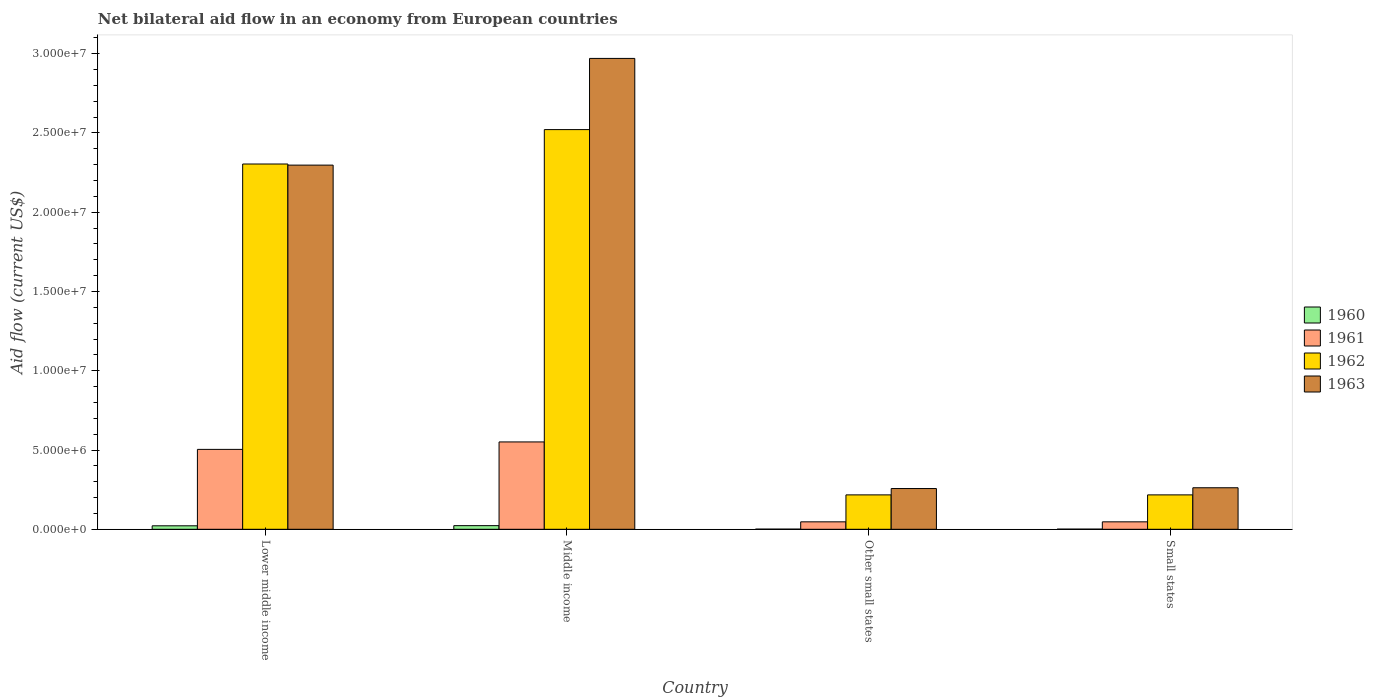How many groups of bars are there?
Offer a very short reply. 4. Are the number of bars per tick equal to the number of legend labels?
Your response must be concise. Yes. Are the number of bars on each tick of the X-axis equal?
Your response must be concise. Yes. How many bars are there on the 3rd tick from the right?
Keep it short and to the point. 4. What is the label of the 1st group of bars from the left?
Keep it short and to the point. Lower middle income. In how many cases, is the number of bars for a given country not equal to the number of legend labels?
Your answer should be compact. 0. What is the net bilateral aid flow in 1963 in Small states?
Provide a succinct answer. 2.62e+06. Across all countries, what is the maximum net bilateral aid flow in 1961?
Provide a short and direct response. 5.51e+06. In which country was the net bilateral aid flow in 1962 maximum?
Provide a short and direct response. Middle income. In which country was the net bilateral aid flow in 1963 minimum?
Give a very brief answer. Other small states. What is the total net bilateral aid flow in 1960 in the graph?
Ensure brevity in your answer.  4.70e+05. What is the difference between the net bilateral aid flow in 1960 in Lower middle income and the net bilateral aid flow in 1962 in Other small states?
Make the answer very short. -1.95e+06. What is the average net bilateral aid flow in 1960 per country?
Provide a succinct answer. 1.18e+05. What is the difference between the net bilateral aid flow of/in 1961 and net bilateral aid flow of/in 1962 in Small states?
Offer a terse response. -1.70e+06. In how many countries, is the net bilateral aid flow in 1961 greater than 6000000 US$?
Offer a terse response. 0. What is the difference between the highest and the second highest net bilateral aid flow in 1963?
Your answer should be very brief. 2.71e+07. What is the difference between the highest and the lowest net bilateral aid flow in 1963?
Keep it short and to the point. 2.71e+07. In how many countries, is the net bilateral aid flow in 1963 greater than the average net bilateral aid flow in 1963 taken over all countries?
Make the answer very short. 2. Is the sum of the net bilateral aid flow in 1962 in Middle income and Small states greater than the maximum net bilateral aid flow in 1960 across all countries?
Your answer should be compact. Yes. Is it the case that in every country, the sum of the net bilateral aid flow in 1963 and net bilateral aid flow in 1960 is greater than the sum of net bilateral aid flow in 1962 and net bilateral aid flow in 1961?
Provide a short and direct response. No. What does the 3rd bar from the right in Other small states represents?
Offer a terse response. 1961. Is it the case that in every country, the sum of the net bilateral aid flow in 1963 and net bilateral aid flow in 1962 is greater than the net bilateral aid flow in 1961?
Keep it short and to the point. Yes. How many bars are there?
Provide a short and direct response. 16. How many countries are there in the graph?
Your answer should be very brief. 4. Are the values on the major ticks of Y-axis written in scientific E-notation?
Offer a terse response. Yes. Does the graph contain any zero values?
Offer a terse response. No. Does the graph contain grids?
Ensure brevity in your answer.  No. How many legend labels are there?
Give a very brief answer. 4. What is the title of the graph?
Give a very brief answer. Net bilateral aid flow in an economy from European countries. Does "1960" appear as one of the legend labels in the graph?
Offer a very short reply. Yes. What is the Aid flow (current US$) in 1961 in Lower middle income?
Your answer should be very brief. 5.04e+06. What is the Aid flow (current US$) of 1962 in Lower middle income?
Offer a very short reply. 2.30e+07. What is the Aid flow (current US$) in 1963 in Lower middle income?
Make the answer very short. 2.30e+07. What is the Aid flow (current US$) in 1960 in Middle income?
Offer a terse response. 2.30e+05. What is the Aid flow (current US$) in 1961 in Middle income?
Your answer should be very brief. 5.51e+06. What is the Aid flow (current US$) of 1962 in Middle income?
Keep it short and to the point. 2.52e+07. What is the Aid flow (current US$) in 1963 in Middle income?
Keep it short and to the point. 2.97e+07. What is the Aid flow (current US$) of 1961 in Other small states?
Provide a short and direct response. 4.70e+05. What is the Aid flow (current US$) in 1962 in Other small states?
Keep it short and to the point. 2.17e+06. What is the Aid flow (current US$) of 1963 in Other small states?
Your answer should be compact. 2.57e+06. What is the Aid flow (current US$) in 1960 in Small states?
Your answer should be compact. 10000. What is the Aid flow (current US$) in 1961 in Small states?
Give a very brief answer. 4.70e+05. What is the Aid flow (current US$) of 1962 in Small states?
Provide a short and direct response. 2.17e+06. What is the Aid flow (current US$) in 1963 in Small states?
Make the answer very short. 2.62e+06. Across all countries, what is the maximum Aid flow (current US$) in 1961?
Keep it short and to the point. 5.51e+06. Across all countries, what is the maximum Aid flow (current US$) of 1962?
Your response must be concise. 2.52e+07. Across all countries, what is the maximum Aid flow (current US$) of 1963?
Offer a terse response. 2.97e+07. Across all countries, what is the minimum Aid flow (current US$) of 1960?
Your response must be concise. 10000. Across all countries, what is the minimum Aid flow (current US$) of 1961?
Offer a very short reply. 4.70e+05. Across all countries, what is the minimum Aid flow (current US$) in 1962?
Make the answer very short. 2.17e+06. Across all countries, what is the minimum Aid flow (current US$) of 1963?
Your response must be concise. 2.57e+06. What is the total Aid flow (current US$) of 1961 in the graph?
Offer a very short reply. 1.15e+07. What is the total Aid flow (current US$) in 1962 in the graph?
Offer a very short reply. 5.26e+07. What is the total Aid flow (current US$) of 1963 in the graph?
Offer a very short reply. 5.79e+07. What is the difference between the Aid flow (current US$) of 1960 in Lower middle income and that in Middle income?
Give a very brief answer. -10000. What is the difference between the Aid flow (current US$) of 1961 in Lower middle income and that in Middle income?
Make the answer very short. -4.70e+05. What is the difference between the Aid flow (current US$) in 1962 in Lower middle income and that in Middle income?
Keep it short and to the point. -2.17e+06. What is the difference between the Aid flow (current US$) of 1963 in Lower middle income and that in Middle income?
Provide a succinct answer. -6.73e+06. What is the difference between the Aid flow (current US$) in 1960 in Lower middle income and that in Other small states?
Ensure brevity in your answer.  2.10e+05. What is the difference between the Aid flow (current US$) in 1961 in Lower middle income and that in Other small states?
Provide a short and direct response. 4.57e+06. What is the difference between the Aid flow (current US$) in 1962 in Lower middle income and that in Other small states?
Your answer should be very brief. 2.09e+07. What is the difference between the Aid flow (current US$) of 1963 in Lower middle income and that in Other small states?
Offer a terse response. 2.04e+07. What is the difference between the Aid flow (current US$) in 1961 in Lower middle income and that in Small states?
Provide a succinct answer. 4.57e+06. What is the difference between the Aid flow (current US$) in 1962 in Lower middle income and that in Small states?
Make the answer very short. 2.09e+07. What is the difference between the Aid flow (current US$) of 1963 in Lower middle income and that in Small states?
Give a very brief answer. 2.04e+07. What is the difference between the Aid flow (current US$) in 1961 in Middle income and that in Other small states?
Offer a terse response. 5.04e+06. What is the difference between the Aid flow (current US$) of 1962 in Middle income and that in Other small states?
Ensure brevity in your answer.  2.30e+07. What is the difference between the Aid flow (current US$) of 1963 in Middle income and that in Other small states?
Ensure brevity in your answer.  2.71e+07. What is the difference between the Aid flow (current US$) of 1960 in Middle income and that in Small states?
Give a very brief answer. 2.20e+05. What is the difference between the Aid flow (current US$) in 1961 in Middle income and that in Small states?
Keep it short and to the point. 5.04e+06. What is the difference between the Aid flow (current US$) of 1962 in Middle income and that in Small states?
Offer a very short reply. 2.30e+07. What is the difference between the Aid flow (current US$) of 1963 in Middle income and that in Small states?
Ensure brevity in your answer.  2.71e+07. What is the difference between the Aid flow (current US$) in 1962 in Other small states and that in Small states?
Your answer should be very brief. 0. What is the difference between the Aid flow (current US$) in 1963 in Other small states and that in Small states?
Make the answer very short. -5.00e+04. What is the difference between the Aid flow (current US$) in 1960 in Lower middle income and the Aid flow (current US$) in 1961 in Middle income?
Your answer should be compact. -5.29e+06. What is the difference between the Aid flow (current US$) in 1960 in Lower middle income and the Aid flow (current US$) in 1962 in Middle income?
Offer a terse response. -2.50e+07. What is the difference between the Aid flow (current US$) of 1960 in Lower middle income and the Aid flow (current US$) of 1963 in Middle income?
Ensure brevity in your answer.  -2.95e+07. What is the difference between the Aid flow (current US$) in 1961 in Lower middle income and the Aid flow (current US$) in 1962 in Middle income?
Make the answer very short. -2.02e+07. What is the difference between the Aid flow (current US$) in 1961 in Lower middle income and the Aid flow (current US$) in 1963 in Middle income?
Make the answer very short. -2.47e+07. What is the difference between the Aid flow (current US$) of 1962 in Lower middle income and the Aid flow (current US$) of 1963 in Middle income?
Your answer should be compact. -6.66e+06. What is the difference between the Aid flow (current US$) of 1960 in Lower middle income and the Aid flow (current US$) of 1962 in Other small states?
Offer a very short reply. -1.95e+06. What is the difference between the Aid flow (current US$) in 1960 in Lower middle income and the Aid flow (current US$) in 1963 in Other small states?
Give a very brief answer. -2.35e+06. What is the difference between the Aid flow (current US$) in 1961 in Lower middle income and the Aid flow (current US$) in 1962 in Other small states?
Provide a short and direct response. 2.87e+06. What is the difference between the Aid flow (current US$) in 1961 in Lower middle income and the Aid flow (current US$) in 1963 in Other small states?
Provide a succinct answer. 2.47e+06. What is the difference between the Aid flow (current US$) of 1962 in Lower middle income and the Aid flow (current US$) of 1963 in Other small states?
Give a very brief answer. 2.05e+07. What is the difference between the Aid flow (current US$) of 1960 in Lower middle income and the Aid flow (current US$) of 1962 in Small states?
Your response must be concise. -1.95e+06. What is the difference between the Aid flow (current US$) in 1960 in Lower middle income and the Aid flow (current US$) in 1963 in Small states?
Give a very brief answer. -2.40e+06. What is the difference between the Aid flow (current US$) of 1961 in Lower middle income and the Aid flow (current US$) of 1962 in Small states?
Make the answer very short. 2.87e+06. What is the difference between the Aid flow (current US$) of 1961 in Lower middle income and the Aid flow (current US$) of 1963 in Small states?
Your answer should be compact. 2.42e+06. What is the difference between the Aid flow (current US$) of 1962 in Lower middle income and the Aid flow (current US$) of 1963 in Small states?
Provide a short and direct response. 2.04e+07. What is the difference between the Aid flow (current US$) in 1960 in Middle income and the Aid flow (current US$) in 1962 in Other small states?
Make the answer very short. -1.94e+06. What is the difference between the Aid flow (current US$) in 1960 in Middle income and the Aid flow (current US$) in 1963 in Other small states?
Offer a very short reply. -2.34e+06. What is the difference between the Aid flow (current US$) of 1961 in Middle income and the Aid flow (current US$) of 1962 in Other small states?
Make the answer very short. 3.34e+06. What is the difference between the Aid flow (current US$) of 1961 in Middle income and the Aid flow (current US$) of 1963 in Other small states?
Ensure brevity in your answer.  2.94e+06. What is the difference between the Aid flow (current US$) in 1962 in Middle income and the Aid flow (current US$) in 1963 in Other small states?
Give a very brief answer. 2.26e+07. What is the difference between the Aid flow (current US$) of 1960 in Middle income and the Aid flow (current US$) of 1961 in Small states?
Provide a short and direct response. -2.40e+05. What is the difference between the Aid flow (current US$) in 1960 in Middle income and the Aid flow (current US$) in 1962 in Small states?
Provide a succinct answer. -1.94e+06. What is the difference between the Aid flow (current US$) of 1960 in Middle income and the Aid flow (current US$) of 1963 in Small states?
Provide a short and direct response. -2.39e+06. What is the difference between the Aid flow (current US$) in 1961 in Middle income and the Aid flow (current US$) in 1962 in Small states?
Offer a terse response. 3.34e+06. What is the difference between the Aid flow (current US$) in 1961 in Middle income and the Aid flow (current US$) in 1963 in Small states?
Offer a very short reply. 2.89e+06. What is the difference between the Aid flow (current US$) of 1962 in Middle income and the Aid flow (current US$) of 1963 in Small states?
Offer a terse response. 2.26e+07. What is the difference between the Aid flow (current US$) in 1960 in Other small states and the Aid flow (current US$) in 1961 in Small states?
Your answer should be very brief. -4.60e+05. What is the difference between the Aid flow (current US$) in 1960 in Other small states and the Aid flow (current US$) in 1962 in Small states?
Offer a very short reply. -2.16e+06. What is the difference between the Aid flow (current US$) in 1960 in Other small states and the Aid flow (current US$) in 1963 in Small states?
Your answer should be compact. -2.61e+06. What is the difference between the Aid flow (current US$) of 1961 in Other small states and the Aid flow (current US$) of 1962 in Small states?
Give a very brief answer. -1.70e+06. What is the difference between the Aid flow (current US$) in 1961 in Other small states and the Aid flow (current US$) in 1963 in Small states?
Your answer should be compact. -2.15e+06. What is the difference between the Aid flow (current US$) in 1962 in Other small states and the Aid flow (current US$) in 1963 in Small states?
Make the answer very short. -4.50e+05. What is the average Aid flow (current US$) of 1960 per country?
Keep it short and to the point. 1.18e+05. What is the average Aid flow (current US$) in 1961 per country?
Your answer should be very brief. 2.87e+06. What is the average Aid flow (current US$) of 1962 per country?
Ensure brevity in your answer.  1.31e+07. What is the average Aid flow (current US$) of 1963 per country?
Keep it short and to the point. 1.45e+07. What is the difference between the Aid flow (current US$) in 1960 and Aid flow (current US$) in 1961 in Lower middle income?
Keep it short and to the point. -4.82e+06. What is the difference between the Aid flow (current US$) of 1960 and Aid flow (current US$) of 1962 in Lower middle income?
Ensure brevity in your answer.  -2.28e+07. What is the difference between the Aid flow (current US$) of 1960 and Aid flow (current US$) of 1963 in Lower middle income?
Provide a succinct answer. -2.28e+07. What is the difference between the Aid flow (current US$) of 1961 and Aid flow (current US$) of 1962 in Lower middle income?
Make the answer very short. -1.80e+07. What is the difference between the Aid flow (current US$) of 1961 and Aid flow (current US$) of 1963 in Lower middle income?
Offer a terse response. -1.79e+07. What is the difference between the Aid flow (current US$) of 1960 and Aid flow (current US$) of 1961 in Middle income?
Ensure brevity in your answer.  -5.28e+06. What is the difference between the Aid flow (current US$) in 1960 and Aid flow (current US$) in 1962 in Middle income?
Your response must be concise. -2.50e+07. What is the difference between the Aid flow (current US$) in 1960 and Aid flow (current US$) in 1963 in Middle income?
Provide a short and direct response. -2.95e+07. What is the difference between the Aid flow (current US$) in 1961 and Aid flow (current US$) in 1962 in Middle income?
Offer a terse response. -1.97e+07. What is the difference between the Aid flow (current US$) in 1961 and Aid flow (current US$) in 1963 in Middle income?
Keep it short and to the point. -2.42e+07. What is the difference between the Aid flow (current US$) of 1962 and Aid flow (current US$) of 1963 in Middle income?
Your answer should be very brief. -4.49e+06. What is the difference between the Aid flow (current US$) of 1960 and Aid flow (current US$) of 1961 in Other small states?
Provide a short and direct response. -4.60e+05. What is the difference between the Aid flow (current US$) of 1960 and Aid flow (current US$) of 1962 in Other small states?
Provide a succinct answer. -2.16e+06. What is the difference between the Aid flow (current US$) in 1960 and Aid flow (current US$) in 1963 in Other small states?
Provide a short and direct response. -2.56e+06. What is the difference between the Aid flow (current US$) in 1961 and Aid flow (current US$) in 1962 in Other small states?
Provide a short and direct response. -1.70e+06. What is the difference between the Aid flow (current US$) of 1961 and Aid flow (current US$) of 1963 in Other small states?
Your answer should be compact. -2.10e+06. What is the difference between the Aid flow (current US$) in 1962 and Aid flow (current US$) in 1963 in Other small states?
Your answer should be very brief. -4.00e+05. What is the difference between the Aid flow (current US$) in 1960 and Aid flow (current US$) in 1961 in Small states?
Ensure brevity in your answer.  -4.60e+05. What is the difference between the Aid flow (current US$) in 1960 and Aid flow (current US$) in 1962 in Small states?
Your response must be concise. -2.16e+06. What is the difference between the Aid flow (current US$) of 1960 and Aid flow (current US$) of 1963 in Small states?
Offer a very short reply. -2.61e+06. What is the difference between the Aid flow (current US$) in 1961 and Aid flow (current US$) in 1962 in Small states?
Provide a succinct answer. -1.70e+06. What is the difference between the Aid flow (current US$) of 1961 and Aid flow (current US$) of 1963 in Small states?
Your answer should be compact. -2.15e+06. What is the difference between the Aid flow (current US$) of 1962 and Aid flow (current US$) of 1963 in Small states?
Offer a very short reply. -4.50e+05. What is the ratio of the Aid flow (current US$) in 1960 in Lower middle income to that in Middle income?
Provide a short and direct response. 0.96. What is the ratio of the Aid flow (current US$) in 1961 in Lower middle income to that in Middle income?
Make the answer very short. 0.91. What is the ratio of the Aid flow (current US$) of 1962 in Lower middle income to that in Middle income?
Make the answer very short. 0.91. What is the ratio of the Aid flow (current US$) of 1963 in Lower middle income to that in Middle income?
Your answer should be very brief. 0.77. What is the ratio of the Aid flow (current US$) in 1960 in Lower middle income to that in Other small states?
Offer a very short reply. 22. What is the ratio of the Aid flow (current US$) of 1961 in Lower middle income to that in Other small states?
Offer a very short reply. 10.72. What is the ratio of the Aid flow (current US$) of 1962 in Lower middle income to that in Other small states?
Offer a very short reply. 10.62. What is the ratio of the Aid flow (current US$) of 1963 in Lower middle income to that in Other small states?
Offer a terse response. 8.94. What is the ratio of the Aid flow (current US$) in 1961 in Lower middle income to that in Small states?
Provide a short and direct response. 10.72. What is the ratio of the Aid flow (current US$) of 1962 in Lower middle income to that in Small states?
Ensure brevity in your answer.  10.62. What is the ratio of the Aid flow (current US$) of 1963 in Lower middle income to that in Small states?
Make the answer very short. 8.77. What is the ratio of the Aid flow (current US$) in 1960 in Middle income to that in Other small states?
Your response must be concise. 23. What is the ratio of the Aid flow (current US$) of 1961 in Middle income to that in Other small states?
Your answer should be compact. 11.72. What is the ratio of the Aid flow (current US$) in 1962 in Middle income to that in Other small states?
Keep it short and to the point. 11.62. What is the ratio of the Aid flow (current US$) of 1963 in Middle income to that in Other small states?
Offer a terse response. 11.56. What is the ratio of the Aid flow (current US$) of 1960 in Middle income to that in Small states?
Ensure brevity in your answer.  23. What is the ratio of the Aid flow (current US$) in 1961 in Middle income to that in Small states?
Give a very brief answer. 11.72. What is the ratio of the Aid flow (current US$) in 1962 in Middle income to that in Small states?
Your answer should be compact. 11.62. What is the ratio of the Aid flow (current US$) of 1963 in Middle income to that in Small states?
Provide a short and direct response. 11.34. What is the ratio of the Aid flow (current US$) in 1960 in Other small states to that in Small states?
Your response must be concise. 1. What is the ratio of the Aid flow (current US$) in 1961 in Other small states to that in Small states?
Your response must be concise. 1. What is the ratio of the Aid flow (current US$) in 1962 in Other small states to that in Small states?
Provide a short and direct response. 1. What is the ratio of the Aid flow (current US$) of 1963 in Other small states to that in Small states?
Your answer should be very brief. 0.98. What is the difference between the highest and the second highest Aid flow (current US$) in 1961?
Offer a terse response. 4.70e+05. What is the difference between the highest and the second highest Aid flow (current US$) of 1962?
Offer a very short reply. 2.17e+06. What is the difference between the highest and the second highest Aid flow (current US$) in 1963?
Provide a short and direct response. 6.73e+06. What is the difference between the highest and the lowest Aid flow (current US$) of 1961?
Ensure brevity in your answer.  5.04e+06. What is the difference between the highest and the lowest Aid flow (current US$) in 1962?
Offer a very short reply. 2.30e+07. What is the difference between the highest and the lowest Aid flow (current US$) in 1963?
Offer a very short reply. 2.71e+07. 